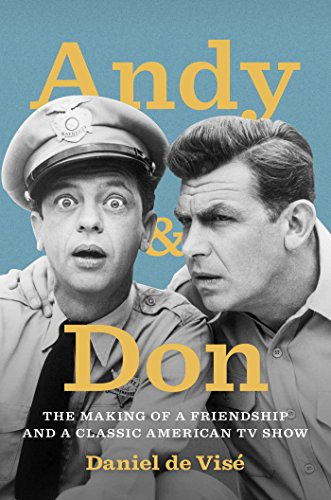Is this book related to Engineering & Transportation? No, this book is not tied to the 'Engineering & Transportation' category; it's firmly rooted in the world of television history and the comedic arts. 